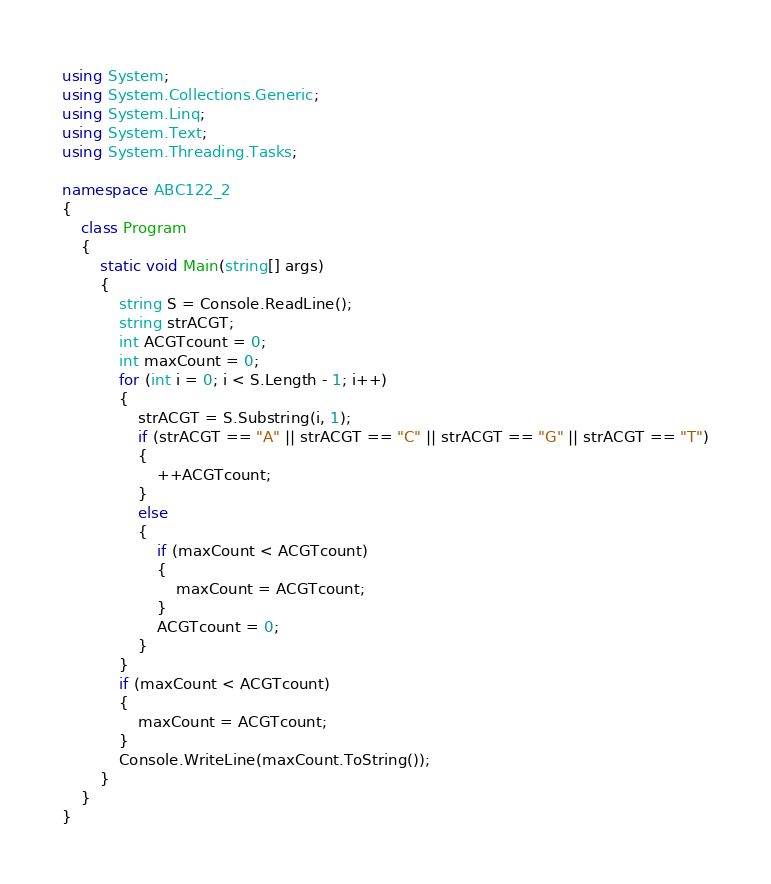Convert code to text. <code><loc_0><loc_0><loc_500><loc_500><_C#_>using System;
using System.Collections.Generic;
using System.Linq;
using System.Text;
using System.Threading.Tasks;

namespace ABC122_2
{
    class Program
    {
        static void Main(string[] args)
        {
            string S = Console.ReadLine();
            string strACGT;
            int ACGTcount = 0;
            int maxCount = 0;
            for (int i = 0; i < S.Length - 1; i++)
            {
                strACGT = S.Substring(i, 1);
                if (strACGT == "A" || strACGT == "C" || strACGT == "G" || strACGT == "T")
                {
                    ++ACGTcount;
                }
                else
                {
                    if (maxCount < ACGTcount)
                    {
                        maxCount = ACGTcount;
                    }
                    ACGTcount = 0;
                }
            }
            if (maxCount < ACGTcount)
            {
                maxCount = ACGTcount;
            }
            Console.WriteLine(maxCount.ToString());
        }
    }
}
</code> 